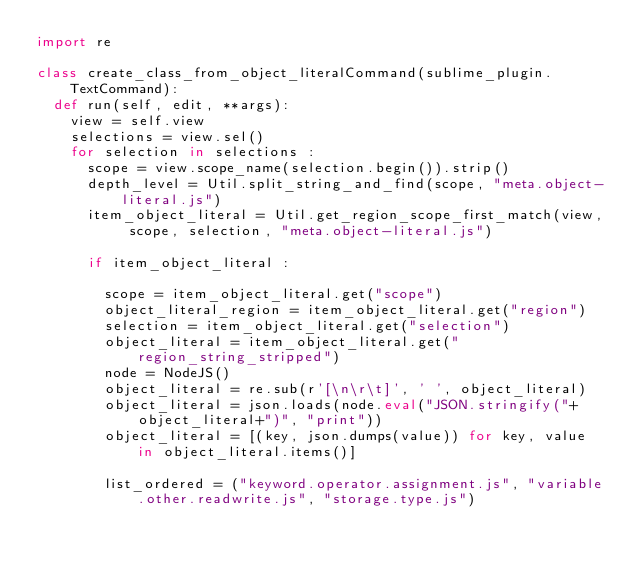Convert code to text. <code><loc_0><loc_0><loc_500><loc_500><_Python_>import re

class create_class_from_object_literalCommand(sublime_plugin.TextCommand):
  def run(self, edit, **args):
    view = self.view
    selections = view.sel()
    for selection in selections :
      scope = view.scope_name(selection.begin()).strip()
      depth_level = Util.split_string_and_find(scope, "meta.object-literal.js")
      item_object_literal = Util.get_region_scope_first_match(view, scope, selection, "meta.object-literal.js")

      if item_object_literal :

        scope = item_object_literal.get("scope")
        object_literal_region = item_object_literal.get("region")
        selection = item_object_literal.get("selection")
        object_literal = item_object_literal.get("region_string_stripped")
        node = NodeJS()
        object_literal = re.sub(r'[\n\r\t]', ' ', object_literal)
        object_literal = json.loads(node.eval("JSON.stringify("+object_literal+")", "print"))
        object_literal = [(key, json.dumps(value)) for key, value in object_literal.items()]

        list_ordered = ("keyword.operator.assignment.js", "variable.other.readwrite.js", "storage.type.js")</code> 